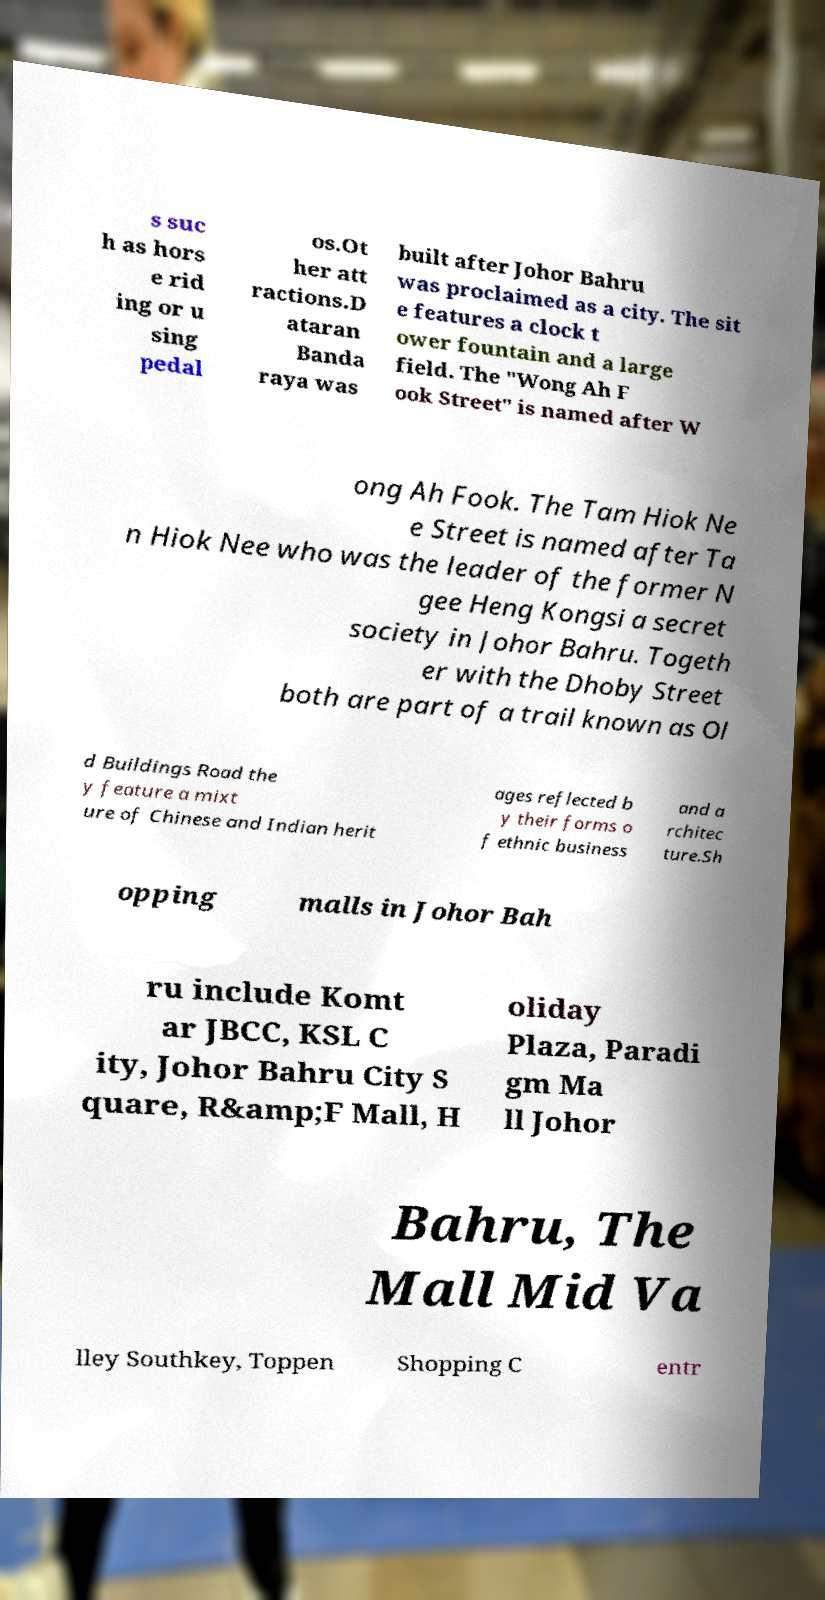Please read and relay the text visible in this image. What does it say? s suc h as hors e rid ing or u sing pedal os.Ot her att ractions.D ataran Banda raya was built after Johor Bahru was proclaimed as a city. The sit e features a clock t ower fountain and a large field. The "Wong Ah F ook Street" is named after W ong Ah Fook. The Tam Hiok Ne e Street is named after Ta n Hiok Nee who was the leader of the former N gee Heng Kongsi a secret society in Johor Bahru. Togeth er with the Dhoby Street both are part of a trail known as Ol d Buildings Road the y feature a mixt ure of Chinese and Indian herit ages reflected b y their forms o f ethnic business and a rchitec ture.Sh opping malls in Johor Bah ru include Komt ar JBCC, KSL C ity, Johor Bahru City S quare, R&amp;F Mall, H oliday Plaza, Paradi gm Ma ll Johor Bahru, The Mall Mid Va lley Southkey, Toppen Shopping C entr 